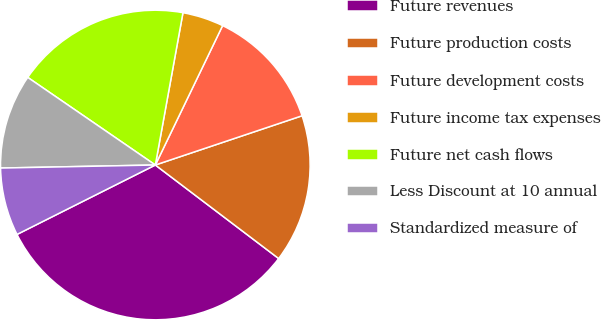<chart> <loc_0><loc_0><loc_500><loc_500><pie_chart><fcel>Future revenues<fcel>Future production costs<fcel>Future development costs<fcel>Future income tax expenses<fcel>Future net cash flows<fcel>Less Discount at 10 annual<fcel>Standardized measure of<nl><fcel>32.27%<fcel>15.48%<fcel>12.69%<fcel>4.3%<fcel>18.28%<fcel>9.89%<fcel>7.09%<nl></chart> 